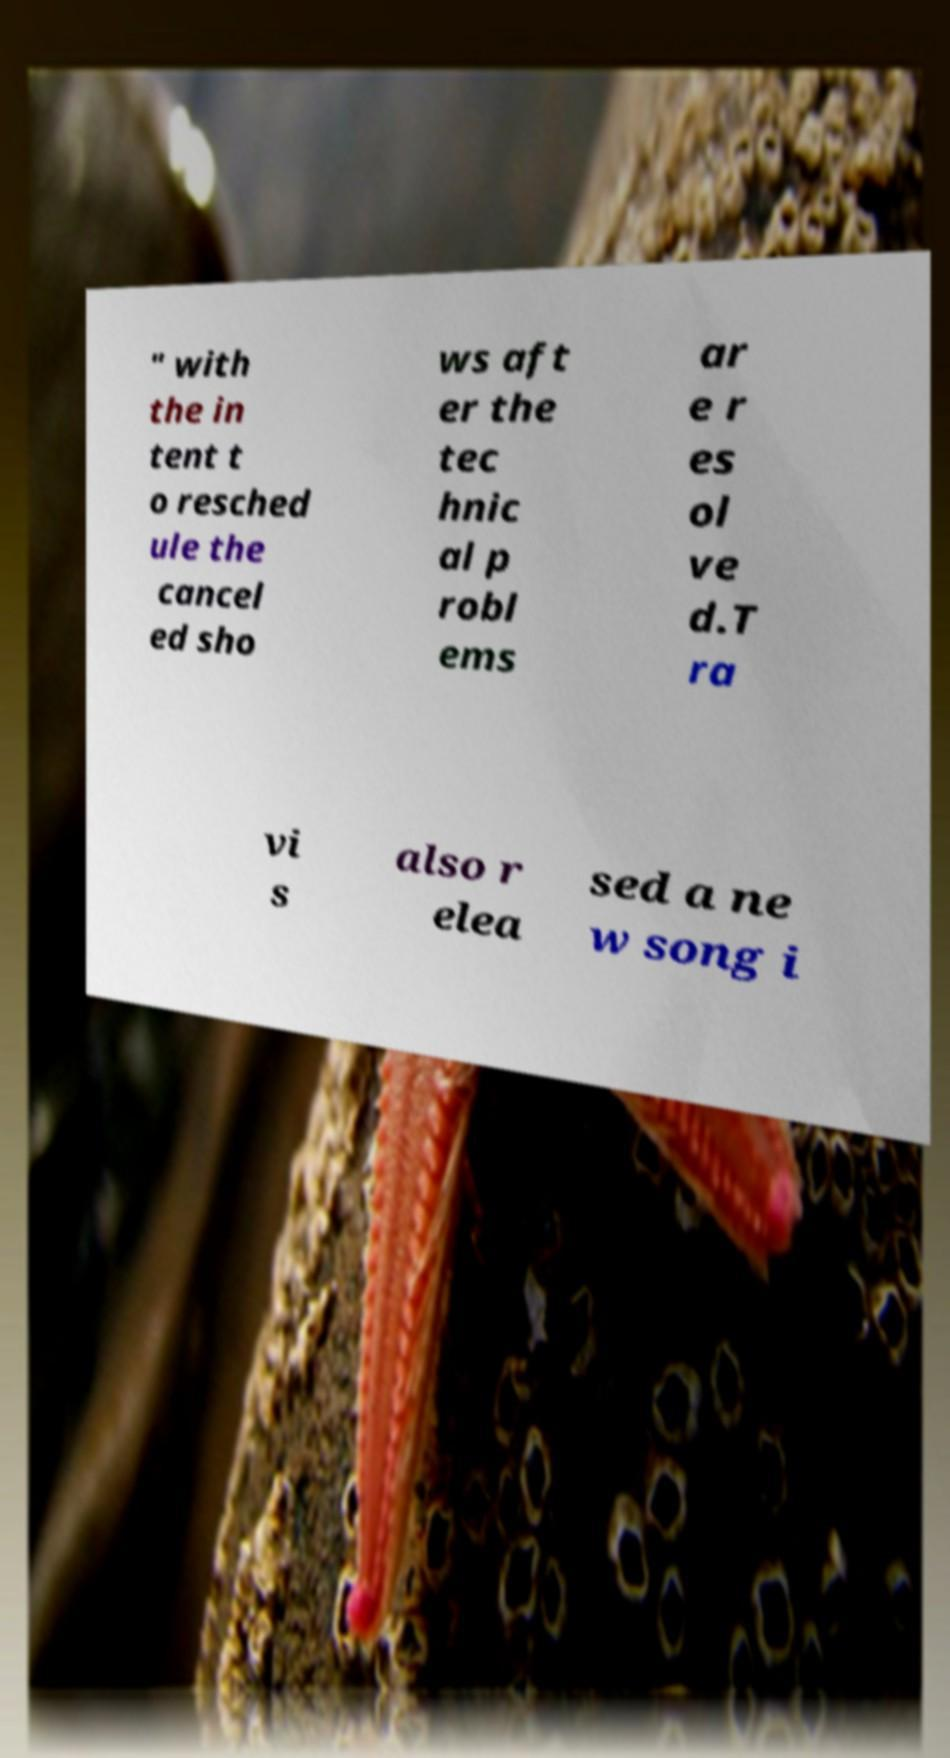Can you accurately transcribe the text from the provided image for me? " with the in tent t o resched ule the cancel ed sho ws aft er the tec hnic al p robl ems ar e r es ol ve d.T ra vi s also r elea sed a ne w song i 